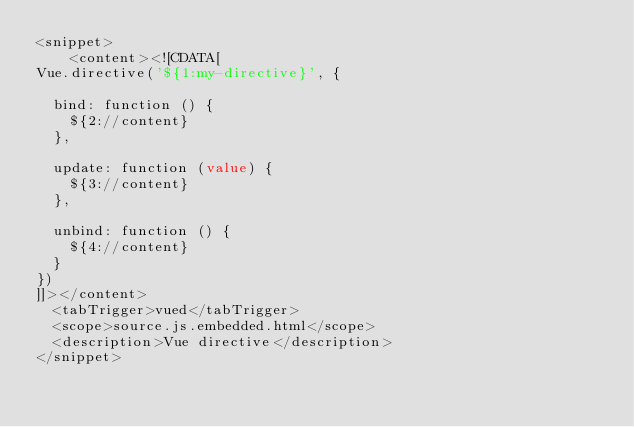<code> <loc_0><loc_0><loc_500><loc_500><_XML_><snippet>
    <content><![CDATA[
Vue.directive('${1:my-directive}', {

  bind: function () {
    ${2://content}
  },

  update: function (value) {
    ${3://content}
  },

  unbind: function () {
    ${4://content}
  }
})
]]></content>
  <tabTrigger>vued</tabTrigger>
  <scope>source.js.embedded.html</scope>
  <description>Vue directive</description>
</snippet>
</code> 